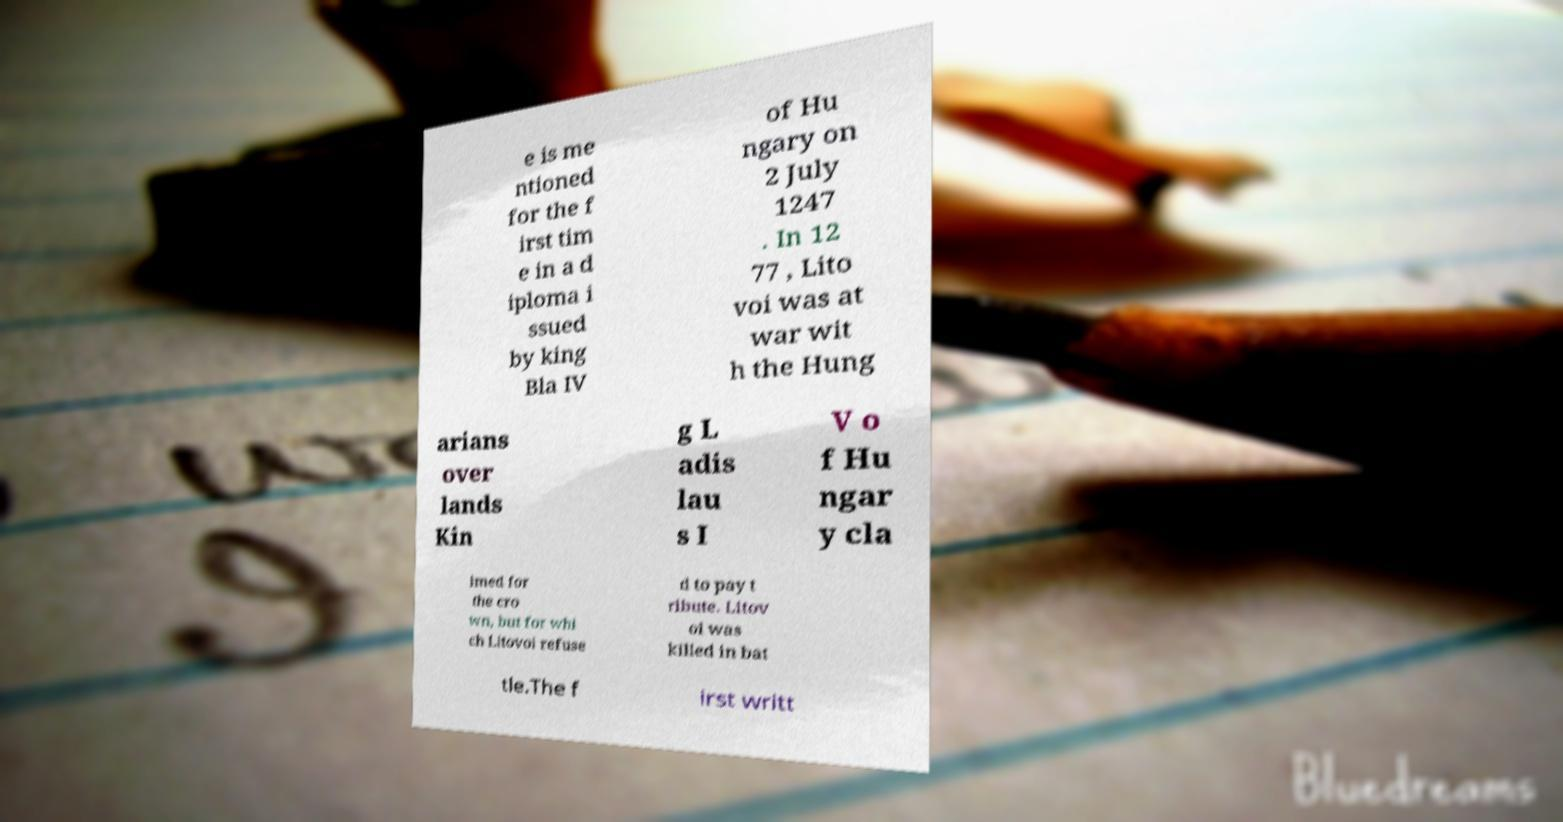Please identify and transcribe the text found in this image. e is me ntioned for the f irst tim e in a d iploma i ssued by king Bla IV of Hu ngary on 2 July 1247 . In 12 77 , Lito voi was at war wit h the Hung arians over lands Kin g L adis lau s I V o f Hu ngar y cla imed for the cro wn, but for whi ch Litovoi refuse d to pay t ribute. Litov oi was killed in bat tle.The f irst writt 